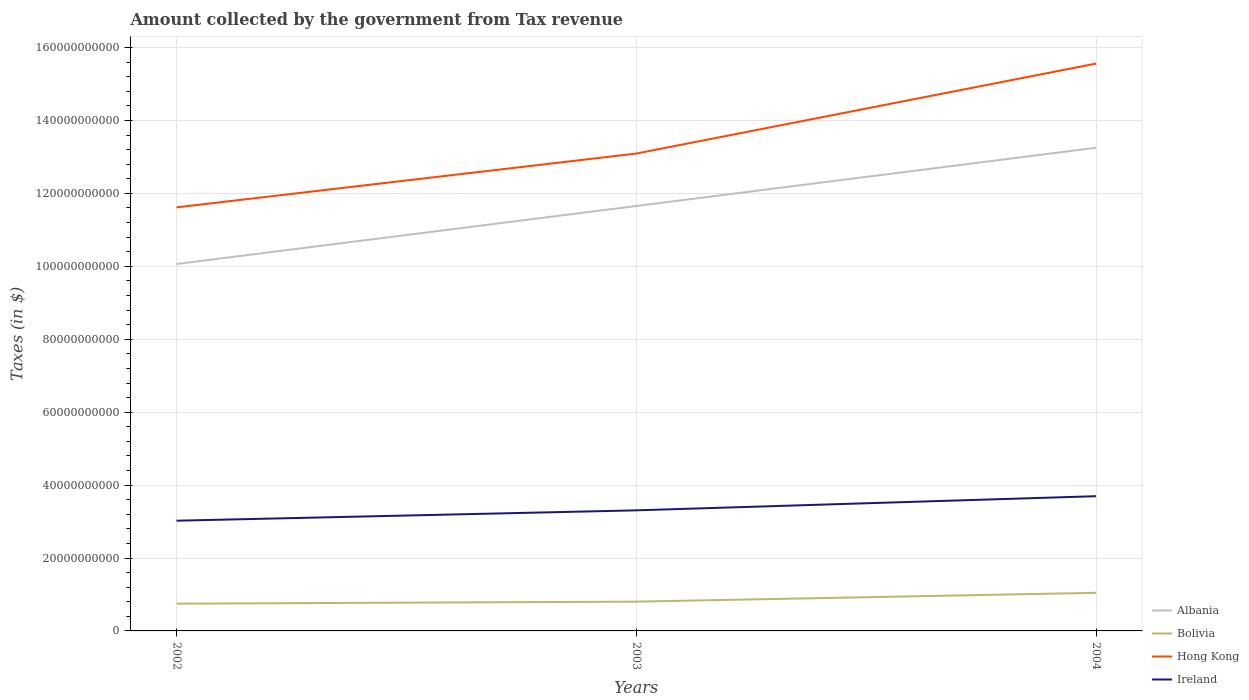How many different coloured lines are there?
Keep it short and to the point. 4. Across all years, what is the maximum amount collected by the government from tax revenue in Albania?
Offer a very short reply. 1.01e+11. In which year was the amount collected by the government from tax revenue in Hong Kong maximum?
Provide a short and direct response. 2002. What is the total amount collected by the government from tax revenue in Ireland in the graph?
Your answer should be compact. -6.72e+09. What is the difference between the highest and the second highest amount collected by the government from tax revenue in Hong Kong?
Provide a short and direct response. 3.94e+1. Is the amount collected by the government from tax revenue in Hong Kong strictly greater than the amount collected by the government from tax revenue in Ireland over the years?
Ensure brevity in your answer.  No. How many years are there in the graph?
Give a very brief answer. 3. Are the values on the major ticks of Y-axis written in scientific E-notation?
Offer a terse response. No. Does the graph contain grids?
Your response must be concise. Yes. How are the legend labels stacked?
Ensure brevity in your answer.  Vertical. What is the title of the graph?
Provide a short and direct response. Amount collected by the government from Tax revenue. Does "Slovenia" appear as one of the legend labels in the graph?
Your response must be concise. No. What is the label or title of the Y-axis?
Keep it short and to the point. Taxes (in $). What is the Taxes (in $) in Albania in 2002?
Make the answer very short. 1.01e+11. What is the Taxes (in $) of Bolivia in 2002?
Give a very brief answer. 7.47e+09. What is the Taxes (in $) of Hong Kong in 2002?
Give a very brief answer. 1.16e+11. What is the Taxes (in $) of Ireland in 2002?
Your response must be concise. 3.02e+1. What is the Taxes (in $) of Albania in 2003?
Offer a terse response. 1.17e+11. What is the Taxes (in $) of Bolivia in 2003?
Your response must be concise. 8.03e+09. What is the Taxes (in $) of Hong Kong in 2003?
Your response must be concise. 1.31e+11. What is the Taxes (in $) of Ireland in 2003?
Your answer should be compact. 3.31e+1. What is the Taxes (in $) of Albania in 2004?
Offer a terse response. 1.33e+11. What is the Taxes (in $) in Bolivia in 2004?
Ensure brevity in your answer.  1.05e+1. What is the Taxes (in $) in Hong Kong in 2004?
Provide a succinct answer. 1.56e+11. What is the Taxes (in $) in Ireland in 2004?
Offer a terse response. 3.70e+1. Across all years, what is the maximum Taxes (in $) of Albania?
Offer a terse response. 1.33e+11. Across all years, what is the maximum Taxes (in $) in Bolivia?
Provide a succinct answer. 1.05e+1. Across all years, what is the maximum Taxes (in $) in Hong Kong?
Ensure brevity in your answer.  1.56e+11. Across all years, what is the maximum Taxes (in $) of Ireland?
Your answer should be compact. 3.70e+1. Across all years, what is the minimum Taxes (in $) of Albania?
Your answer should be compact. 1.01e+11. Across all years, what is the minimum Taxes (in $) in Bolivia?
Ensure brevity in your answer.  7.47e+09. Across all years, what is the minimum Taxes (in $) of Hong Kong?
Provide a succinct answer. 1.16e+11. Across all years, what is the minimum Taxes (in $) in Ireland?
Provide a short and direct response. 3.02e+1. What is the total Taxes (in $) of Albania in the graph?
Make the answer very short. 3.50e+11. What is the total Taxes (in $) in Bolivia in the graph?
Your response must be concise. 2.60e+1. What is the total Taxes (in $) of Hong Kong in the graph?
Offer a terse response. 4.03e+11. What is the total Taxes (in $) of Ireland in the graph?
Keep it short and to the point. 1.00e+11. What is the difference between the Taxes (in $) of Albania in 2002 and that in 2003?
Your answer should be very brief. -1.59e+1. What is the difference between the Taxes (in $) in Bolivia in 2002 and that in 2003?
Your response must be concise. -5.58e+08. What is the difference between the Taxes (in $) in Hong Kong in 2002 and that in 2003?
Your response must be concise. -1.48e+1. What is the difference between the Taxes (in $) in Ireland in 2002 and that in 2003?
Give a very brief answer. -2.84e+09. What is the difference between the Taxes (in $) in Albania in 2002 and that in 2004?
Offer a very short reply. -3.19e+1. What is the difference between the Taxes (in $) of Bolivia in 2002 and that in 2004?
Ensure brevity in your answer.  -2.98e+09. What is the difference between the Taxes (in $) in Hong Kong in 2002 and that in 2004?
Offer a terse response. -3.94e+1. What is the difference between the Taxes (in $) in Ireland in 2002 and that in 2004?
Make the answer very short. -6.72e+09. What is the difference between the Taxes (in $) in Albania in 2003 and that in 2004?
Offer a very short reply. -1.60e+1. What is the difference between the Taxes (in $) of Bolivia in 2003 and that in 2004?
Make the answer very short. -2.42e+09. What is the difference between the Taxes (in $) of Hong Kong in 2003 and that in 2004?
Your answer should be compact. -2.47e+1. What is the difference between the Taxes (in $) of Ireland in 2003 and that in 2004?
Keep it short and to the point. -3.88e+09. What is the difference between the Taxes (in $) of Albania in 2002 and the Taxes (in $) of Bolivia in 2003?
Give a very brief answer. 9.26e+1. What is the difference between the Taxes (in $) of Albania in 2002 and the Taxes (in $) of Hong Kong in 2003?
Offer a very short reply. -3.03e+1. What is the difference between the Taxes (in $) of Albania in 2002 and the Taxes (in $) of Ireland in 2003?
Provide a short and direct response. 6.76e+1. What is the difference between the Taxes (in $) in Bolivia in 2002 and the Taxes (in $) in Hong Kong in 2003?
Offer a very short reply. -1.23e+11. What is the difference between the Taxes (in $) of Bolivia in 2002 and the Taxes (in $) of Ireland in 2003?
Your response must be concise. -2.56e+1. What is the difference between the Taxes (in $) in Hong Kong in 2002 and the Taxes (in $) in Ireland in 2003?
Your answer should be compact. 8.31e+1. What is the difference between the Taxes (in $) in Albania in 2002 and the Taxes (in $) in Bolivia in 2004?
Your response must be concise. 9.02e+1. What is the difference between the Taxes (in $) of Albania in 2002 and the Taxes (in $) of Hong Kong in 2004?
Your answer should be compact. -5.50e+1. What is the difference between the Taxes (in $) in Albania in 2002 and the Taxes (in $) in Ireland in 2004?
Offer a terse response. 6.37e+1. What is the difference between the Taxes (in $) in Bolivia in 2002 and the Taxes (in $) in Hong Kong in 2004?
Provide a succinct answer. -1.48e+11. What is the difference between the Taxes (in $) of Bolivia in 2002 and the Taxes (in $) of Ireland in 2004?
Your response must be concise. -2.95e+1. What is the difference between the Taxes (in $) in Hong Kong in 2002 and the Taxes (in $) in Ireland in 2004?
Offer a very short reply. 7.92e+1. What is the difference between the Taxes (in $) in Albania in 2003 and the Taxes (in $) in Bolivia in 2004?
Provide a short and direct response. 1.06e+11. What is the difference between the Taxes (in $) of Albania in 2003 and the Taxes (in $) of Hong Kong in 2004?
Offer a terse response. -3.91e+1. What is the difference between the Taxes (in $) in Albania in 2003 and the Taxes (in $) in Ireland in 2004?
Your answer should be compact. 7.96e+1. What is the difference between the Taxes (in $) of Bolivia in 2003 and the Taxes (in $) of Hong Kong in 2004?
Your response must be concise. -1.48e+11. What is the difference between the Taxes (in $) in Bolivia in 2003 and the Taxes (in $) in Ireland in 2004?
Keep it short and to the point. -2.89e+1. What is the difference between the Taxes (in $) of Hong Kong in 2003 and the Taxes (in $) of Ireland in 2004?
Make the answer very short. 9.40e+1. What is the average Taxes (in $) of Albania per year?
Your answer should be very brief. 1.17e+11. What is the average Taxes (in $) in Bolivia per year?
Provide a short and direct response. 8.65e+09. What is the average Taxes (in $) of Hong Kong per year?
Your answer should be very brief. 1.34e+11. What is the average Taxes (in $) of Ireland per year?
Your answer should be very brief. 3.34e+1. In the year 2002, what is the difference between the Taxes (in $) of Albania and Taxes (in $) of Bolivia?
Make the answer very short. 9.32e+1. In the year 2002, what is the difference between the Taxes (in $) of Albania and Taxes (in $) of Hong Kong?
Make the answer very short. -1.55e+1. In the year 2002, what is the difference between the Taxes (in $) of Albania and Taxes (in $) of Ireland?
Provide a short and direct response. 7.04e+1. In the year 2002, what is the difference between the Taxes (in $) in Bolivia and Taxes (in $) in Hong Kong?
Offer a very short reply. -1.09e+11. In the year 2002, what is the difference between the Taxes (in $) of Bolivia and Taxes (in $) of Ireland?
Provide a short and direct response. -2.28e+1. In the year 2002, what is the difference between the Taxes (in $) of Hong Kong and Taxes (in $) of Ireland?
Keep it short and to the point. 8.59e+1. In the year 2003, what is the difference between the Taxes (in $) in Albania and Taxes (in $) in Bolivia?
Provide a succinct answer. 1.09e+11. In the year 2003, what is the difference between the Taxes (in $) in Albania and Taxes (in $) in Hong Kong?
Give a very brief answer. -1.44e+1. In the year 2003, what is the difference between the Taxes (in $) in Albania and Taxes (in $) in Ireland?
Your answer should be very brief. 8.35e+1. In the year 2003, what is the difference between the Taxes (in $) of Bolivia and Taxes (in $) of Hong Kong?
Give a very brief answer. -1.23e+11. In the year 2003, what is the difference between the Taxes (in $) of Bolivia and Taxes (in $) of Ireland?
Provide a succinct answer. -2.50e+1. In the year 2003, what is the difference between the Taxes (in $) of Hong Kong and Taxes (in $) of Ireland?
Provide a succinct answer. 9.79e+1. In the year 2004, what is the difference between the Taxes (in $) of Albania and Taxes (in $) of Bolivia?
Offer a terse response. 1.22e+11. In the year 2004, what is the difference between the Taxes (in $) in Albania and Taxes (in $) in Hong Kong?
Offer a terse response. -2.31e+1. In the year 2004, what is the difference between the Taxes (in $) in Albania and Taxes (in $) in Ireland?
Ensure brevity in your answer.  9.56e+1. In the year 2004, what is the difference between the Taxes (in $) in Bolivia and Taxes (in $) in Hong Kong?
Offer a very short reply. -1.45e+11. In the year 2004, what is the difference between the Taxes (in $) of Bolivia and Taxes (in $) of Ireland?
Keep it short and to the point. -2.65e+1. In the year 2004, what is the difference between the Taxes (in $) in Hong Kong and Taxes (in $) in Ireland?
Provide a short and direct response. 1.19e+11. What is the ratio of the Taxes (in $) in Albania in 2002 to that in 2003?
Provide a short and direct response. 0.86. What is the ratio of the Taxes (in $) of Bolivia in 2002 to that in 2003?
Your response must be concise. 0.93. What is the ratio of the Taxes (in $) in Hong Kong in 2002 to that in 2003?
Provide a short and direct response. 0.89. What is the ratio of the Taxes (in $) in Ireland in 2002 to that in 2003?
Provide a short and direct response. 0.91. What is the ratio of the Taxes (in $) in Albania in 2002 to that in 2004?
Ensure brevity in your answer.  0.76. What is the ratio of the Taxes (in $) of Bolivia in 2002 to that in 2004?
Keep it short and to the point. 0.71. What is the ratio of the Taxes (in $) of Hong Kong in 2002 to that in 2004?
Offer a terse response. 0.75. What is the ratio of the Taxes (in $) in Ireland in 2002 to that in 2004?
Provide a short and direct response. 0.82. What is the ratio of the Taxes (in $) in Albania in 2003 to that in 2004?
Ensure brevity in your answer.  0.88. What is the ratio of the Taxes (in $) of Bolivia in 2003 to that in 2004?
Keep it short and to the point. 0.77. What is the ratio of the Taxes (in $) of Hong Kong in 2003 to that in 2004?
Offer a terse response. 0.84. What is the ratio of the Taxes (in $) of Ireland in 2003 to that in 2004?
Provide a short and direct response. 0.9. What is the difference between the highest and the second highest Taxes (in $) in Albania?
Your response must be concise. 1.60e+1. What is the difference between the highest and the second highest Taxes (in $) of Bolivia?
Your answer should be compact. 2.42e+09. What is the difference between the highest and the second highest Taxes (in $) in Hong Kong?
Your answer should be very brief. 2.47e+1. What is the difference between the highest and the second highest Taxes (in $) in Ireland?
Your answer should be compact. 3.88e+09. What is the difference between the highest and the lowest Taxes (in $) in Albania?
Give a very brief answer. 3.19e+1. What is the difference between the highest and the lowest Taxes (in $) in Bolivia?
Your response must be concise. 2.98e+09. What is the difference between the highest and the lowest Taxes (in $) of Hong Kong?
Give a very brief answer. 3.94e+1. What is the difference between the highest and the lowest Taxes (in $) in Ireland?
Your answer should be compact. 6.72e+09. 